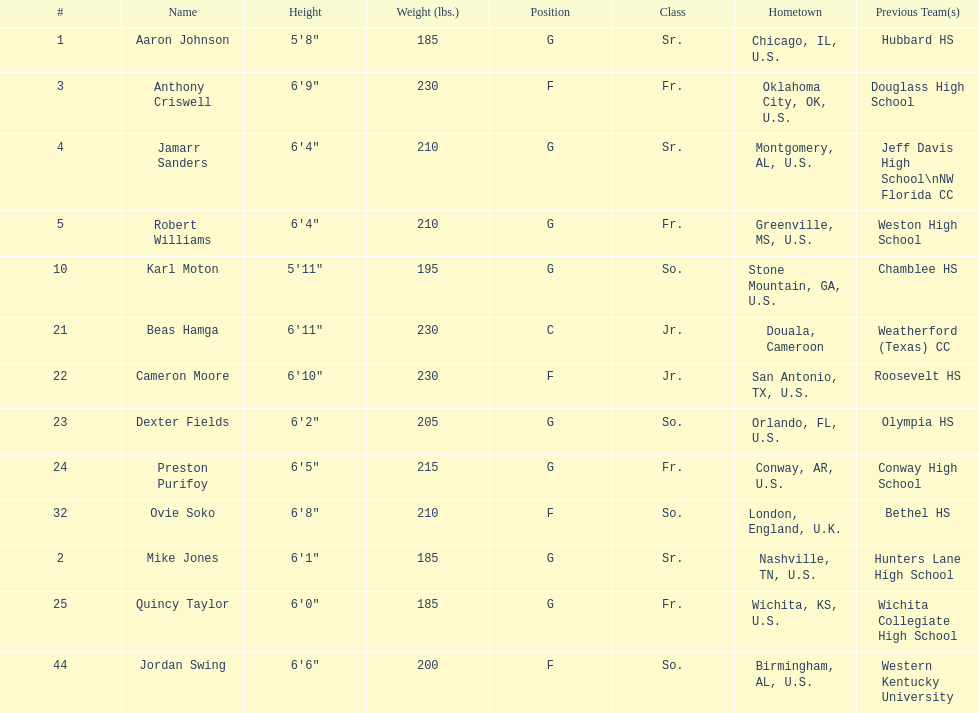What is the difference in weight between dexter fields and quincy taylor? 20. 